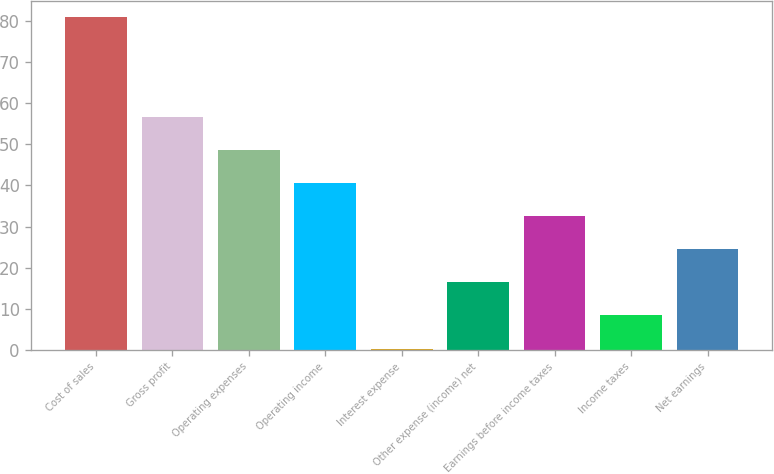Convert chart. <chart><loc_0><loc_0><loc_500><loc_500><bar_chart><fcel>Cost of sales<fcel>Gross profit<fcel>Operating expenses<fcel>Operating income<fcel>Interest expense<fcel>Other expense (income) net<fcel>Earnings before income taxes<fcel>Income taxes<fcel>Net earnings<nl><fcel>80.9<fcel>56.72<fcel>48.66<fcel>40.6<fcel>0.3<fcel>16.42<fcel>32.54<fcel>8.36<fcel>24.48<nl></chart> 